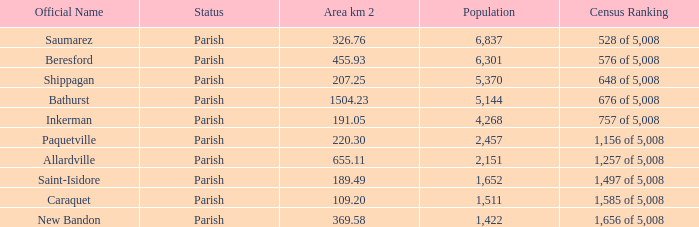76 km²? 1422.0. 